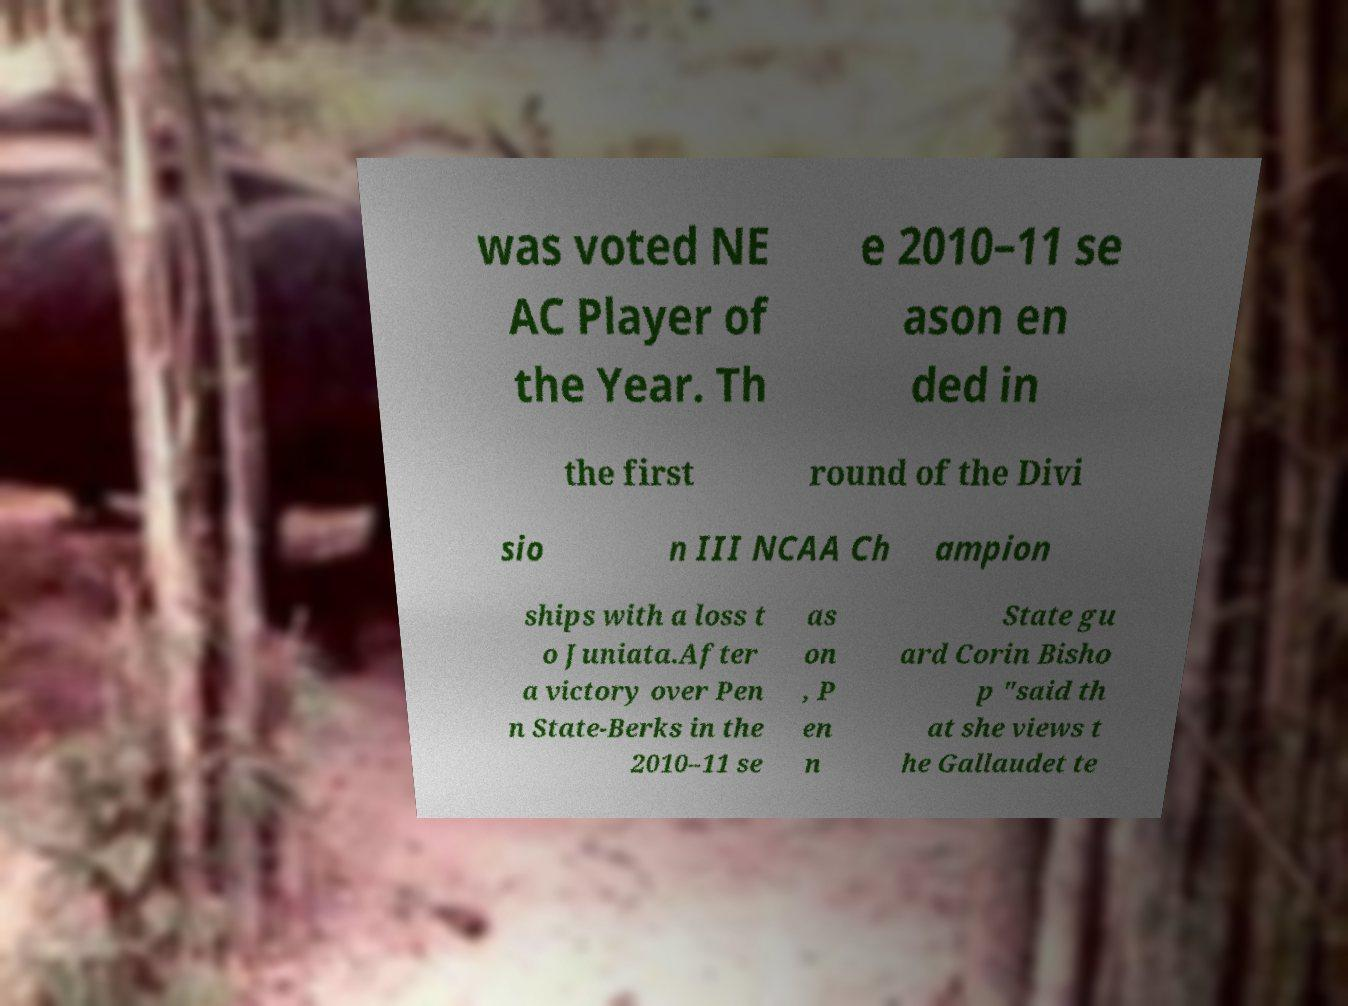There's text embedded in this image that I need extracted. Can you transcribe it verbatim? was voted NE AC Player of the Year. Th e 2010–11 se ason en ded in the first round of the Divi sio n III NCAA Ch ampion ships with a loss t o Juniata.After a victory over Pen n State-Berks in the 2010–11 se as on , P en n State gu ard Corin Bisho p "said th at she views t he Gallaudet te 